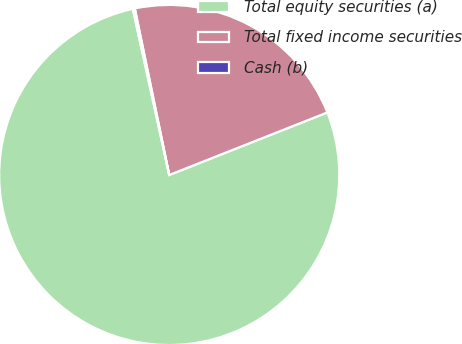Convert chart. <chart><loc_0><loc_0><loc_500><loc_500><pie_chart><fcel>Total equity securities (a)<fcel>Total fixed income securities<fcel>Cash (b)<nl><fcel>77.56%<fcel>22.25%<fcel>0.19%<nl></chart> 